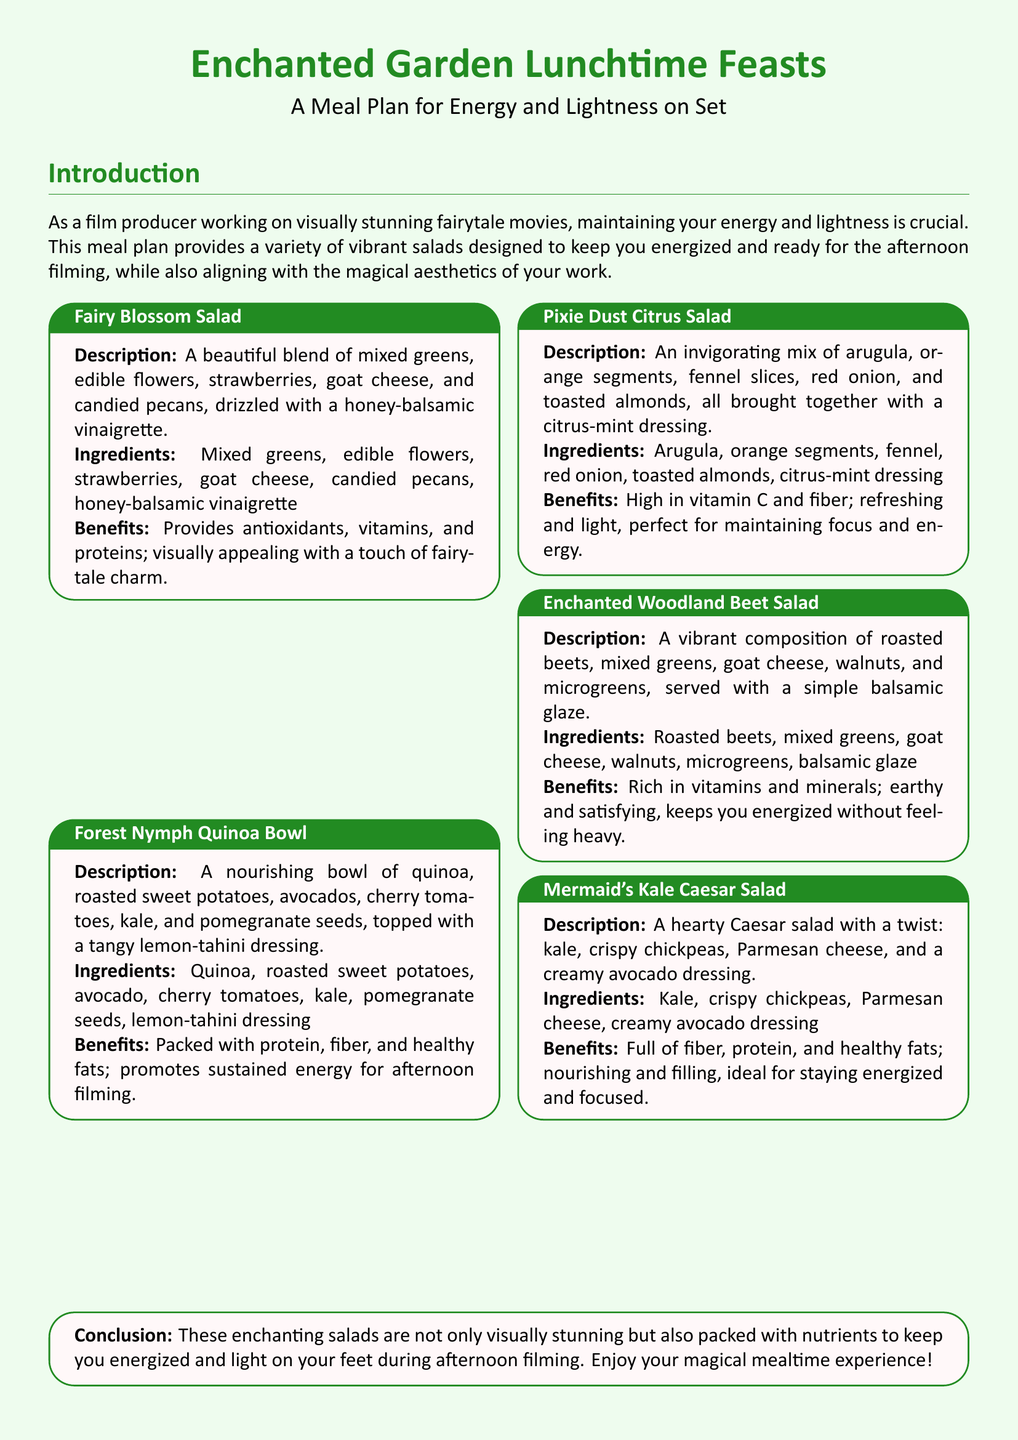What is the title of the meal plan? The title is prominently displayed at the beginning of the document.
Answer: Enchanted Garden Lunchtime Feasts How many salads are featured in the meal plan? The meal plan lists five different salads in total.
Answer: Five What color is used for the background of the document? The background color is specified in the document settings.
Answer: Light green What is the main ingredient in the Fairy Blossom Salad? The description of the Fairy Blossom Salad lists its primary components.
Answer: Mixed greens What dressing is used in the Forest Nymph Quinoa Bowl? The ingredients list for the Forest Nymph Quinoa Bowl mentions its dressing.
Answer: Lemon-tahini dressing What benefits does the Mermaid's Kale Caesar Salad provide? The benefits are clearly stated for each salad in the meal plan.
Answer: Fiber, protein, and healthy fats Which salad contains pomegranate seeds? The ingredients list for the Forest Nymph Quinoa Bowl specifies this ingredient.
Answer: Forest Nymph Quinoa Bowl What type of cheese is used in the Enchanted Woodland Beet Salad? The ingredients stated in the Enchanted Woodland Beet Salad reveal the type of cheese.
Answer: Goat cheese 